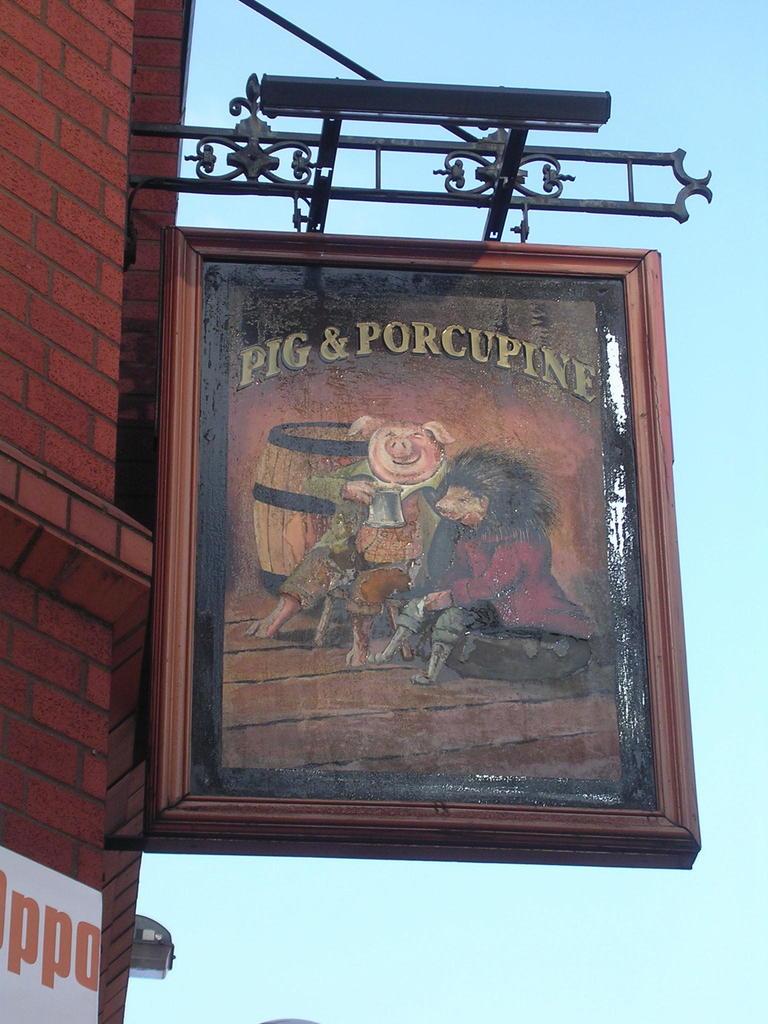What is the name of this business?
Provide a short and direct response. Pig & porcupine. 